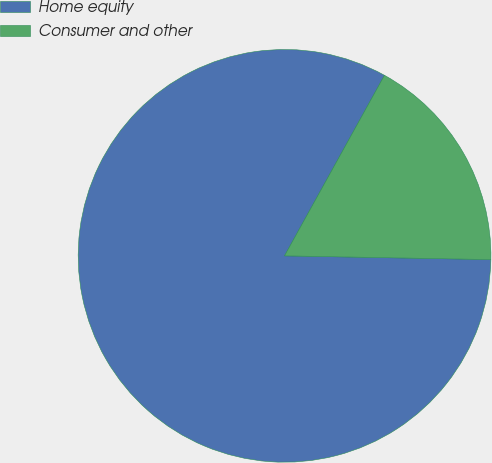<chart> <loc_0><loc_0><loc_500><loc_500><pie_chart><fcel>Home equity<fcel>Consumer and other<nl><fcel>82.76%<fcel>17.24%<nl></chart> 